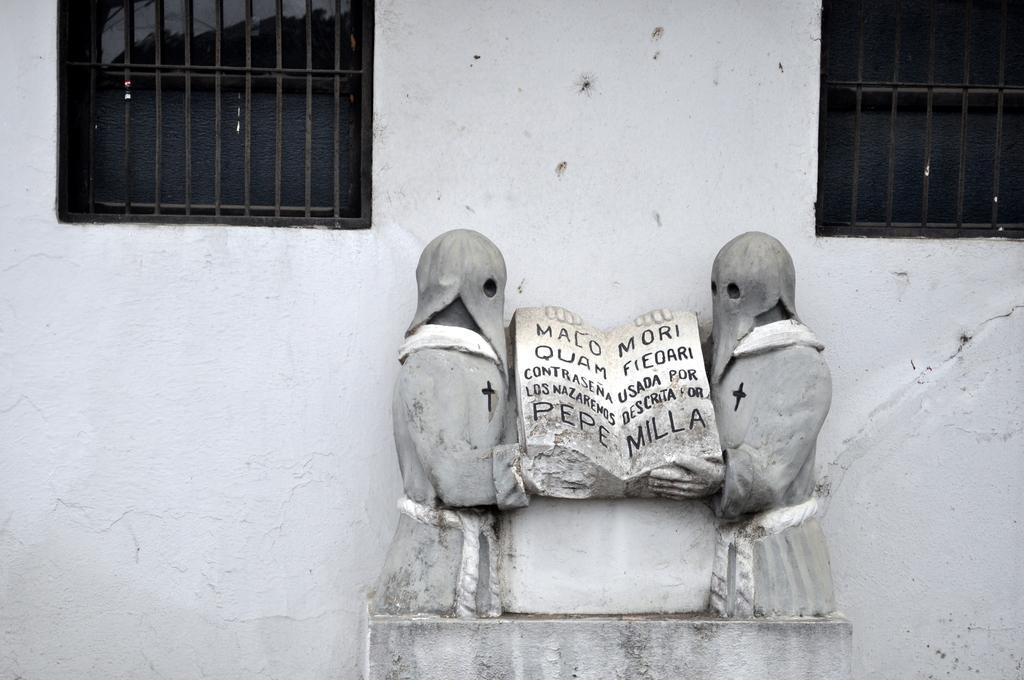In one or two sentences, can you explain what this image depicts? In this image there are sculptures, behind them there are windows with grill rods on the wall. 